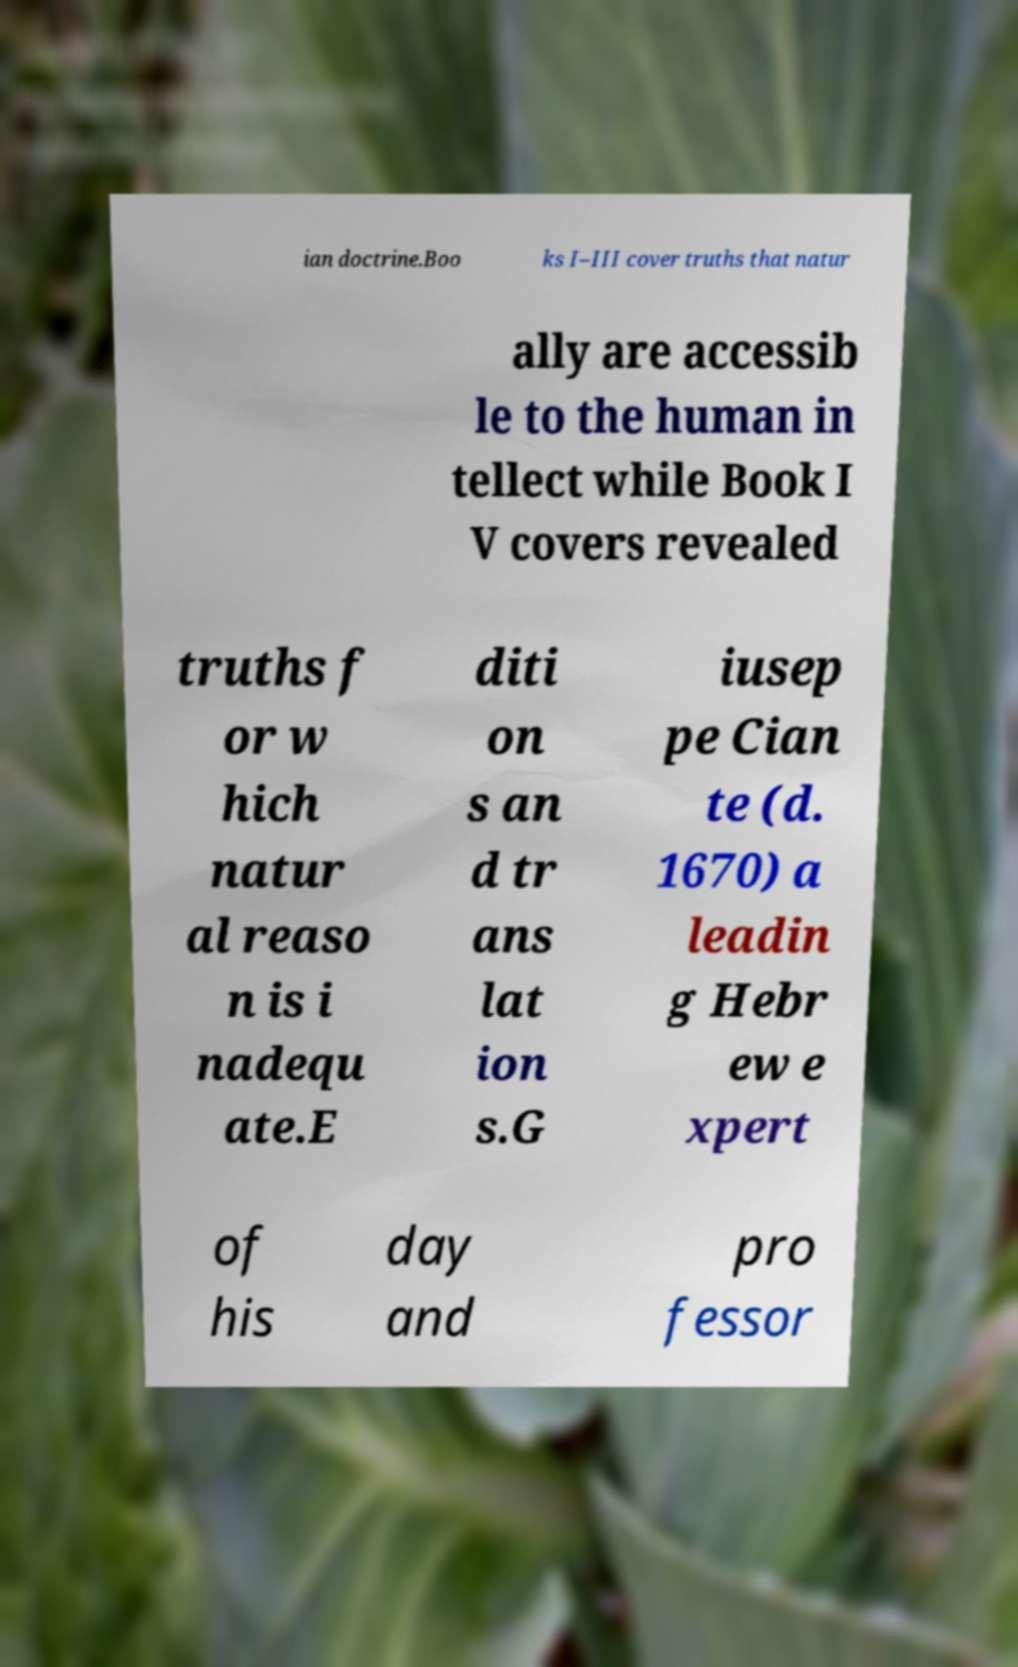What messages or text are displayed in this image? I need them in a readable, typed format. ian doctrine.Boo ks I–III cover truths that natur ally are accessib le to the human in tellect while Book I V covers revealed truths f or w hich natur al reaso n is i nadequ ate.E diti on s an d tr ans lat ion s.G iusep pe Cian te (d. 1670) a leadin g Hebr ew e xpert of his day and pro fessor 